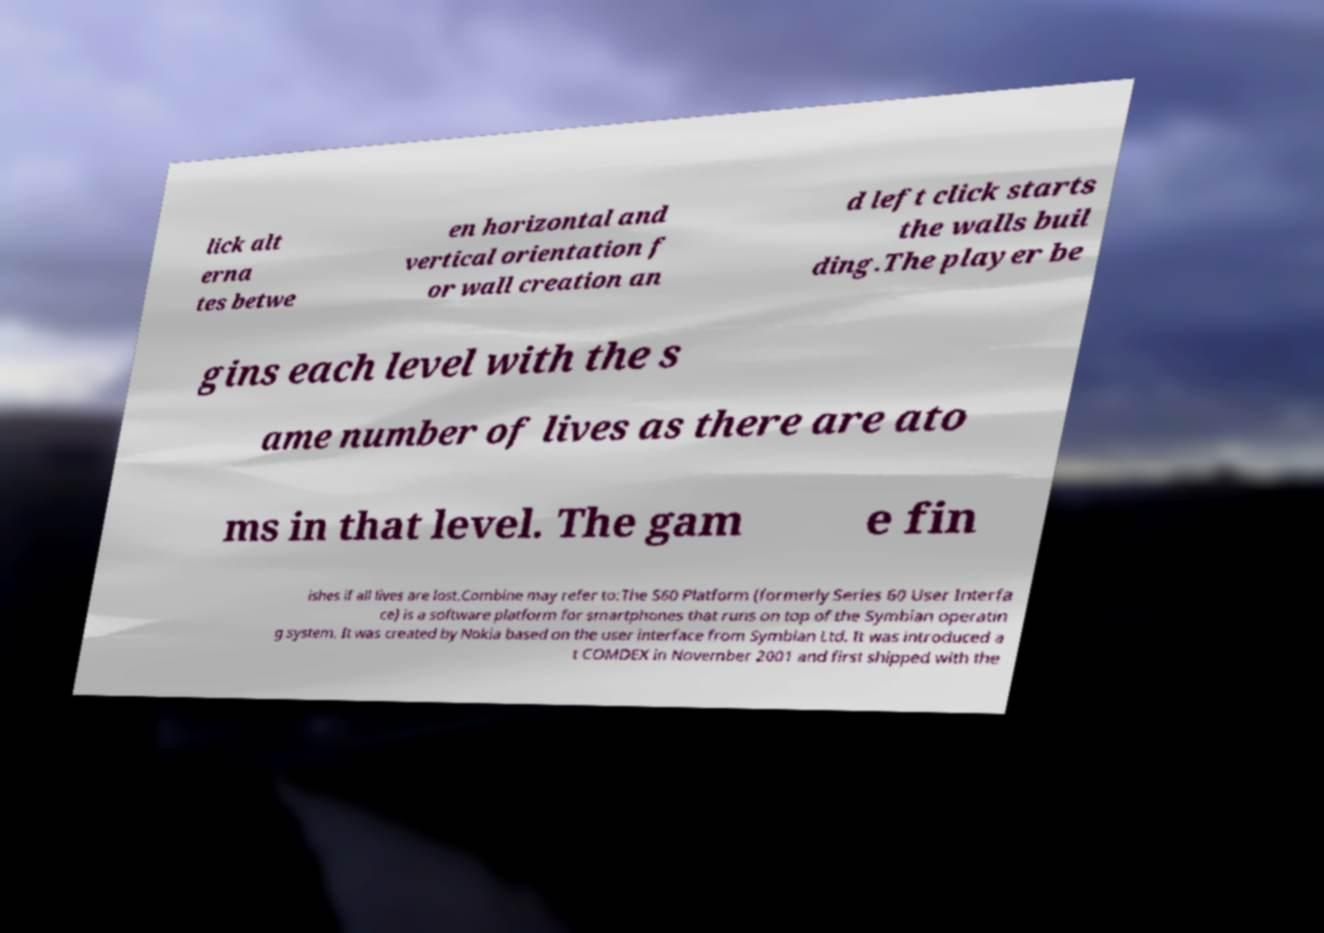Can you read and provide the text displayed in the image?This photo seems to have some interesting text. Can you extract and type it out for me? lick alt erna tes betwe en horizontal and vertical orientation f or wall creation an d left click starts the walls buil ding.The player be gins each level with the s ame number of lives as there are ato ms in that level. The gam e fin ishes if all lives are lost.Combine may refer to:The S60 Platform (formerly Series 60 User Interfa ce) is a software platform for smartphones that runs on top of the Symbian operatin g system. It was created by Nokia based on the user interface from Symbian Ltd. It was introduced a t COMDEX in November 2001 and first shipped with the 